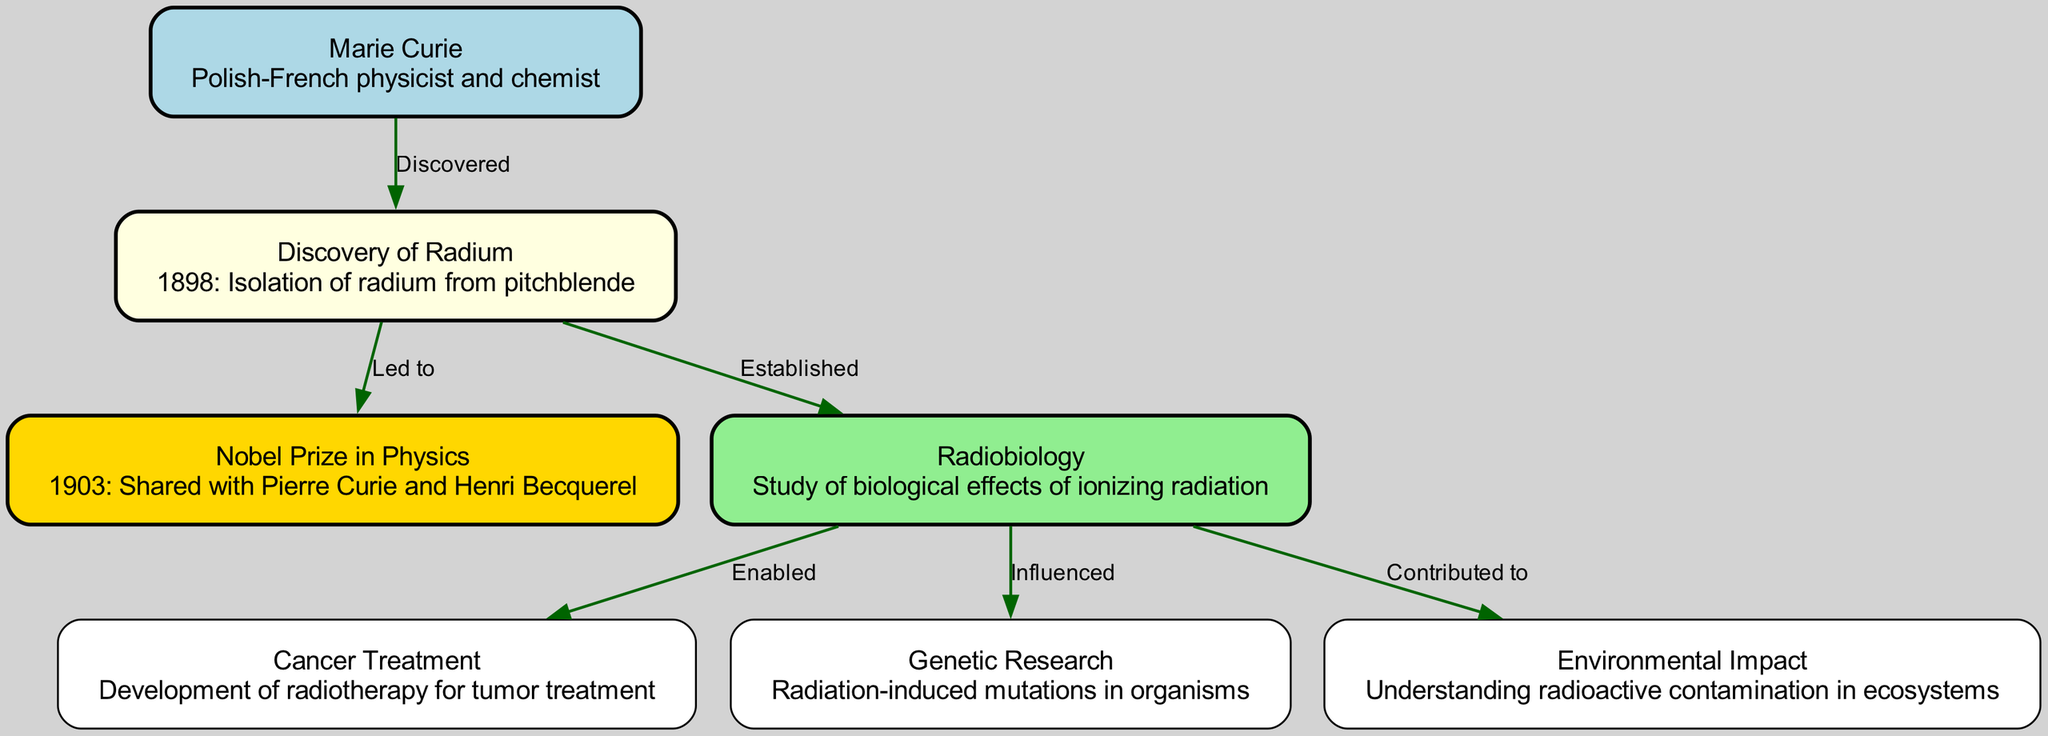What year did Marie Curie discover radium? The diagram states that radium was isolated in 1898, which is directly connected to the node representing Marie Curie.
Answer: 1898 How many Nobel Prizes are mentioned in the timeline? The diagram indicates one Nobel Prize node associated with Marie Curie, specifically the Nobel Prize in Physics in 1903.
Answer: One What did the discovery of radium establish? The edge specifically labels the relationship between the discovery of radium and radiobiology, indicating that radium's discovery established the field of radiobiology.
Answer: Established Which node is influenced by radiobiology? The edges connected to the radiobiology node show two influences, specifically on cancer treatment and genetic research. The question focuses on the relationship that radiobiology has with genetic research.
Answer: Genetic Research What significant application did radiobiology enable? The diagram shows an edge from the radiobiology node to the cancer treatment node, indicating that the biological effects studied in radiobiology enabled the development of radiotherapy for tumor treatment.
Answer: Cancer Treatment Which field studies the biological effects of ionizing radiation? The diagram highlights that radiobiology is the specific field responsible for studying the biological effects of ionizing radiation, as represented in the node dedicated to radiobiology.
Answer: Radiobiology What is the earliest event mentioned in the diagram? The diagram indicates that the earliest event in the timeline is the discovery of radium in 1898, which is the starting point of the research timeline.
Answer: Discovery of Radium How did Marie Curie's research contribute to environmental studies? The edge from the radiobiology node to the environmental impact node illustrates that her research contributed to understanding radioactive contamination in ecosystems, showcasing the broader implications of her work.
Answer: Contributed to What relationship does radium have with the Nobel Prize? The edge between the discovery of radium and the Nobel Prize indicates that the discovery of radium led to Marie Curie sharing the Nobel Prize in Physics in 1903, tying her scientific achievements directly with her recognition in the scientific community.
Answer: Led to 